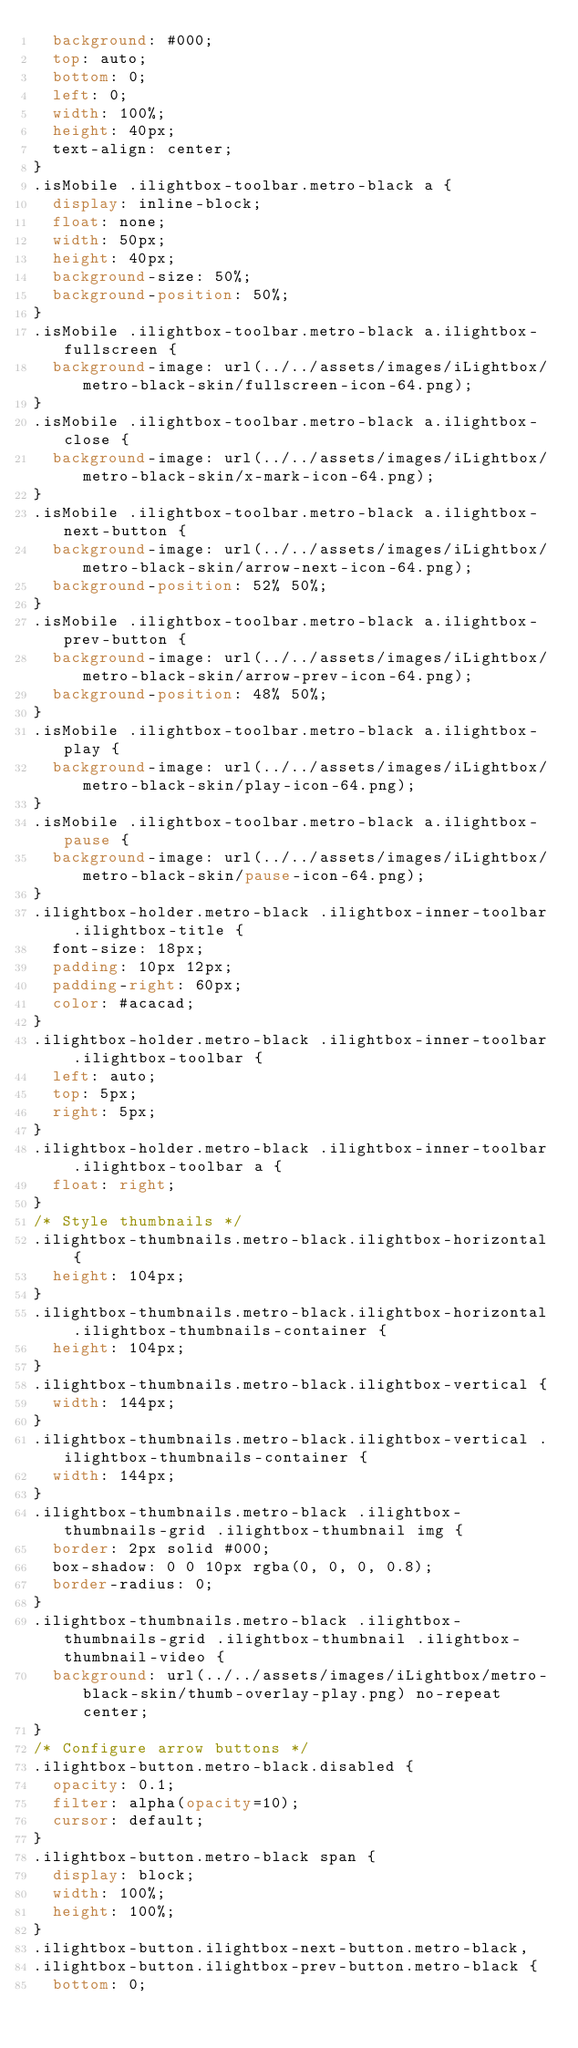Convert code to text. <code><loc_0><loc_0><loc_500><loc_500><_CSS_>  background: #000;
  top: auto;
  bottom: 0;
  left: 0;
  width: 100%;
  height: 40px;
  text-align: center;
}
.isMobile .ilightbox-toolbar.metro-black a {
  display: inline-block;
  float: none;
  width: 50px;
  height: 40px;
  background-size: 50%;
  background-position: 50%;
}
.isMobile .ilightbox-toolbar.metro-black a.ilightbox-fullscreen {
  background-image: url(../../assets/images/iLightbox/metro-black-skin/fullscreen-icon-64.png);
}
.isMobile .ilightbox-toolbar.metro-black a.ilightbox-close {
  background-image: url(../../assets/images/iLightbox/metro-black-skin/x-mark-icon-64.png);
}
.isMobile .ilightbox-toolbar.metro-black a.ilightbox-next-button {
  background-image: url(../../assets/images/iLightbox/metro-black-skin/arrow-next-icon-64.png);
  background-position: 52% 50%;
}
.isMobile .ilightbox-toolbar.metro-black a.ilightbox-prev-button {
  background-image: url(../../assets/images/iLightbox/metro-black-skin/arrow-prev-icon-64.png);
  background-position: 48% 50%;
}
.isMobile .ilightbox-toolbar.metro-black a.ilightbox-play {
  background-image: url(../../assets/images/iLightbox/metro-black-skin/play-icon-64.png);
}
.isMobile .ilightbox-toolbar.metro-black a.ilightbox-pause {
  background-image: url(../../assets/images/iLightbox/metro-black-skin/pause-icon-64.png);
}
.ilightbox-holder.metro-black .ilightbox-inner-toolbar .ilightbox-title {
  font-size: 18px;
  padding: 10px 12px;
  padding-right: 60px;
  color: #acacad;
}
.ilightbox-holder.metro-black .ilightbox-inner-toolbar .ilightbox-toolbar {
  left: auto;
  top: 5px;
  right: 5px;
}
.ilightbox-holder.metro-black .ilightbox-inner-toolbar .ilightbox-toolbar a {
  float: right;
}
/* Style thumbnails */
.ilightbox-thumbnails.metro-black.ilightbox-horizontal {
  height: 104px;
}
.ilightbox-thumbnails.metro-black.ilightbox-horizontal .ilightbox-thumbnails-container {
  height: 104px;
}
.ilightbox-thumbnails.metro-black.ilightbox-vertical {
  width: 144px;
}
.ilightbox-thumbnails.metro-black.ilightbox-vertical .ilightbox-thumbnails-container {
  width: 144px;
}
.ilightbox-thumbnails.metro-black .ilightbox-thumbnails-grid .ilightbox-thumbnail img {
  border: 2px solid #000;
  box-shadow: 0 0 10px rgba(0, 0, 0, 0.8);
  border-radius: 0;
}
.ilightbox-thumbnails.metro-black .ilightbox-thumbnails-grid .ilightbox-thumbnail .ilightbox-thumbnail-video {
  background: url(../../assets/images/iLightbox/metro-black-skin/thumb-overlay-play.png) no-repeat center;
}
/* Configure arrow buttons */
.ilightbox-button.metro-black.disabled {
  opacity: 0.1;
  filter: alpha(opacity=10);
  cursor: default;
}
.ilightbox-button.metro-black span {
  display: block;
  width: 100%;
  height: 100%;
}
.ilightbox-button.ilightbox-next-button.metro-black,
.ilightbox-button.ilightbox-prev-button.metro-black {
  bottom: 0;</code> 